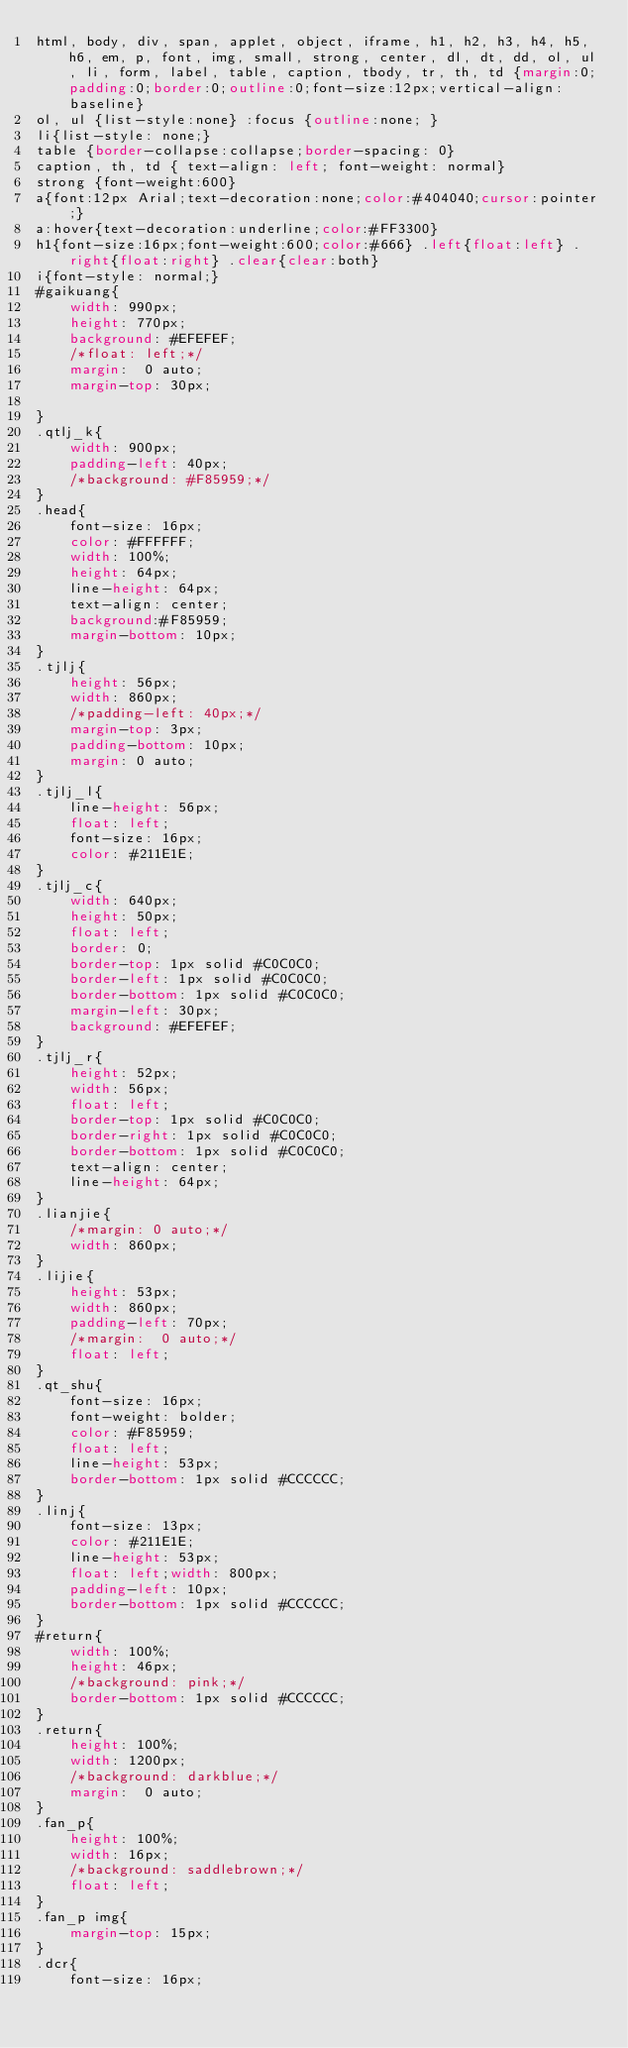<code> <loc_0><loc_0><loc_500><loc_500><_CSS_>html, body, div, span, applet, object, iframe, h1, h2, h3, h4, h5, h6, em, p, font, img, small, strong, center, dl, dt, dd, ol, ul, li, form, label, table, caption, tbody, tr, th, td {margin:0;padding:0;border:0;outline:0;font-size:12px;vertical-align:baseline} 
ol, ul {list-style:none} :focus {outline:none; } 
li{list-style: none;}
table {border-collapse:collapse;border-spacing: 0} 
caption, th, td { text-align: left; font-weight: normal} 
strong {font-weight:600} 
a{font:12px Arial;text-decoration:none;color:#404040;cursor:pointer;} 
a:hover{text-decoration:underline;color:#FF3300} 
h1{font-size:16px;font-weight:600;color:#666} .left{float:left} .right{float:right} .clear{clear:both}
i{font-style: normal;}
#gaikuang{
	width: 990px;
	height: 770px;
	background: #EFEFEF;
	/*float: left;*/
	margin:  0 auto;
	margin-top: 30px;
	
}
.qtlj_k{
	width: 900px;
	padding-left: 40px;
	/*background: #F85959;*/
}
.head{
	font-size: 16px;
	color: #FFFFFF;
	width: 100%;
	height: 64px;
	line-height: 64px;
	text-align: center;
	background:#F85959;
	margin-bottom: 10px;
}
.tjlj{
	height: 56px;
	width: 860px;
	/*padding-left: 40px;*/
	margin-top: 3px;
	padding-bottom: 10px;
	margin: 0 auto;
}
.tjlj_l{
	line-height: 56px;
	float: left;
	font-size: 16px;
	color: #211E1E;
}
.tjlj_c{
	width: 640px;
	height: 50px;
	float: left;
	border: 0;
	border-top: 1px solid #C0C0C0;
	border-left: 1px solid #C0C0C0;
	border-bottom: 1px solid #C0C0C0;
	margin-left: 30px;
	background: #EFEFEF;
}
.tjlj_r{
	height: 52px;
	width: 56px;
	float: left;
	border-top: 1px solid #C0C0C0;
	border-right: 1px solid #C0C0C0;
	border-bottom: 1px solid #C0C0C0;
	text-align: center;
	line-height: 64px;
}
.lianjie{
	/*margin: 0 auto;*/
	width: 860px;
}
.lijie{
	height: 53px;
	width: 860px;
	padding-left: 70px;
	/*margin:  0 auto;*/
	float: left;
}
.qt_shu{
	font-size: 16px;
	font-weight: bolder;
	color: #F85959;
	float: left;
	line-height: 53px;
	border-bottom: 1px solid #CCCCCC;
}
.linj{
	font-size: 13px;
	color: #211E1E;
	line-height: 53px;
	float: left;width: 800px;
	padding-left: 10px;
	border-bottom: 1px solid #CCCCCC;
}
#return{
	width: 100%;
	height: 46px;
	/*background: pink;*/
	border-bottom: 1px solid #CCCCCC;
}
.return{
	height: 100%;
	width: 1200px;
	/*background: darkblue;*/
	margin:  0 auto;
}
.fan_p{
	height: 100%;
	width: 16px;
	/*background: saddlebrown;*/
	float: left;
}
.fan_p img{
	margin-top: 15px;
}
.dcr{
	font-size: 16px;</code> 